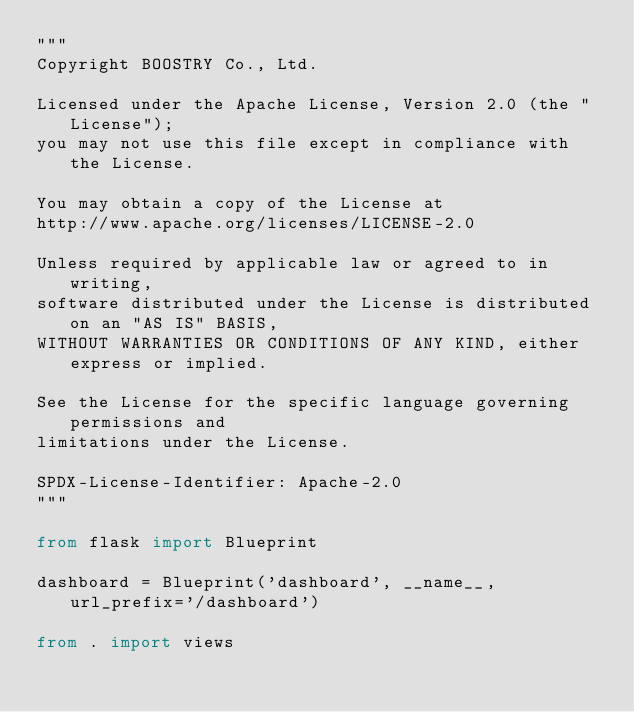<code> <loc_0><loc_0><loc_500><loc_500><_Python_>"""
Copyright BOOSTRY Co., Ltd.

Licensed under the Apache License, Version 2.0 (the "License");
you may not use this file except in compliance with the License.

You may obtain a copy of the License at
http://www.apache.org/licenses/LICENSE-2.0

Unless required by applicable law or agreed to in writing,
software distributed under the License is distributed on an "AS IS" BASIS,
WITHOUT WARRANTIES OR CONDITIONS OF ANY KIND, either express or implied.

See the License for the specific language governing permissions and
limitations under the License.

SPDX-License-Identifier: Apache-2.0
"""

from flask import Blueprint

dashboard = Blueprint('dashboard', __name__, url_prefix='/dashboard')

from . import views
</code> 